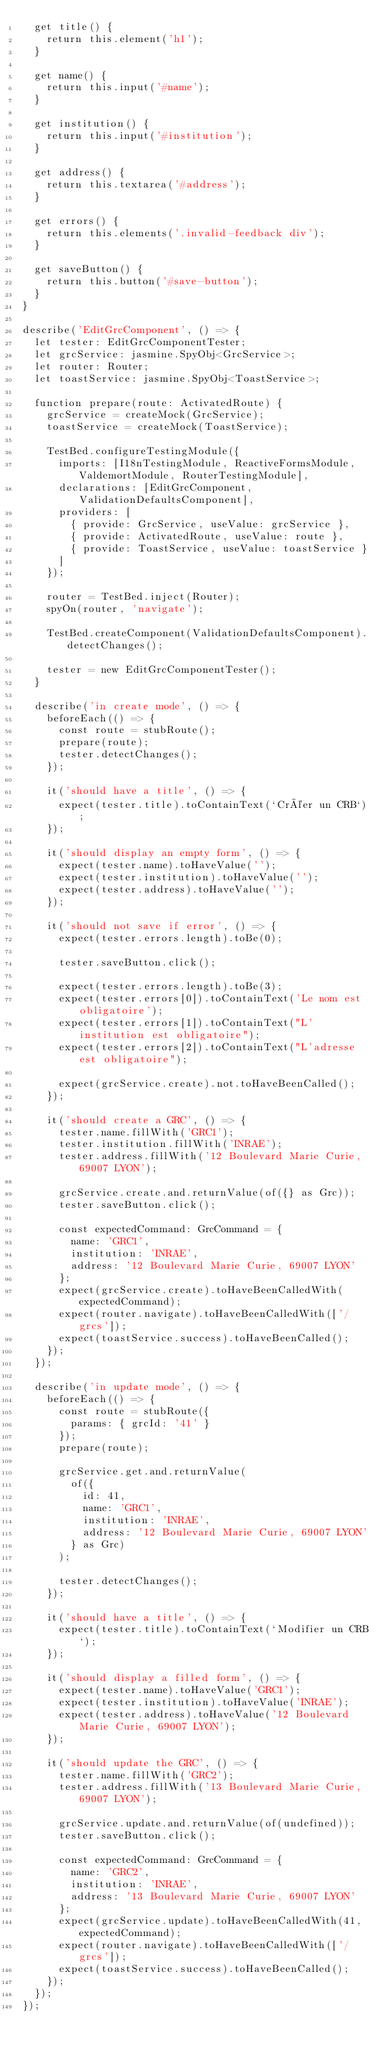<code> <loc_0><loc_0><loc_500><loc_500><_TypeScript_>  get title() {
    return this.element('h1');
  }

  get name() {
    return this.input('#name');
  }

  get institution() {
    return this.input('#institution');
  }

  get address() {
    return this.textarea('#address');
  }

  get errors() {
    return this.elements('.invalid-feedback div');
  }

  get saveButton() {
    return this.button('#save-button');
  }
}

describe('EditGrcComponent', () => {
  let tester: EditGrcComponentTester;
  let grcService: jasmine.SpyObj<GrcService>;
  let router: Router;
  let toastService: jasmine.SpyObj<ToastService>;

  function prepare(route: ActivatedRoute) {
    grcService = createMock(GrcService);
    toastService = createMock(ToastService);

    TestBed.configureTestingModule({
      imports: [I18nTestingModule, ReactiveFormsModule, ValdemortModule, RouterTestingModule],
      declarations: [EditGrcComponent, ValidationDefaultsComponent],
      providers: [
        { provide: GrcService, useValue: grcService },
        { provide: ActivatedRoute, useValue: route },
        { provide: ToastService, useValue: toastService }
      ]
    });

    router = TestBed.inject(Router);
    spyOn(router, 'navigate');

    TestBed.createComponent(ValidationDefaultsComponent).detectChanges();

    tester = new EditGrcComponentTester();
  }

  describe('in create mode', () => {
    beforeEach(() => {
      const route = stubRoute();
      prepare(route);
      tester.detectChanges();
    });

    it('should have a title', () => {
      expect(tester.title).toContainText(`Créer un CRB`);
    });

    it('should display an empty form', () => {
      expect(tester.name).toHaveValue('');
      expect(tester.institution).toHaveValue('');
      expect(tester.address).toHaveValue('');
    });

    it('should not save if error', () => {
      expect(tester.errors.length).toBe(0);

      tester.saveButton.click();

      expect(tester.errors.length).toBe(3);
      expect(tester.errors[0]).toContainText('Le nom est obligatoire');
      expect(tester.errors[1]).toContainText("L'institution est obligatoire");
      expect(tester.errors[2]).toContainText("L'adresse est obligatoire");

      expect(grcService.create).not.toHaveBeenCalled();
    });

    it('should create a GRC', () => {
      tester.name.fillWith('GRC1');
      tester.institution.fillWith('INRAE');
      tester.address.fillWith('12 Boulevard Marie Curie, 69007 LYON');

      grcService.create.and.returnValue(of({} as Grc));
      tester.saveButton.click();

      const expectedCommand: GrcCommand = {
        name: 'GRC1',
        institution: 'INRAE',
        address: '12 Boulevard Marie Curie, 69007 LYON'
      };
      expect(grcService.create).toHaveBeenCalledWith(expectedCommand);
      expect(router.navigate).toHaveBeenCalledWith(['/grcs']);
      expect(toastService.success).toHaveBeenCalled();
    });
  });

  describe('in update mode', () => {
    beforeEach(() => {
      const route = stubRoute({
        params: { grcId: '41' }
      });
      prepare(route);

      grcService.get.and.returnValue(
        of({
          id: 41,
          name: 'GRC1',
          institution: 'INRAE',
          address: '12 Boulevard Marie Curie, 69007 LYON'
        } as Grc)
      );

      tester.detectChanges();
    });

    it('should have a title', () => {
      expect(tester.title).toContainText(`Modifier un CRB`);
    });

    it('should display a filled form', () => {
      expect(tester.name).toHaveValue('GRC1');
      expect(tester.institution).toHaveValue('INRAE');
      expect(tester.address).toHaveValue('12 Boulevard Marie Curie, 69007 LYON');
    });

    it('should update the GRC', () => {
      tester.name.fillWith('GRC2');
      tester.address.fillWith('13 Boulevard Marie Curie, 69007 LYON');

      grcService.update.and.returnValue(of(undefined));
      tester.saveButton.click();

      const expectedCommand: GrcCommand = {
        name: 'GRC2',
        institution: 'INRAE',
        address: '13 Boulevard Marie Curie, 69007 LYON'
      };
      expect(grcService.update).toHaveBeenCalledWith(41, expectedCommand);
      expect(router.navigate).toHaveBeenCalledWith(['/grcs']);
      expect(toastService.success).toHaveBeenCalled();
    });
  });
});
</code> 